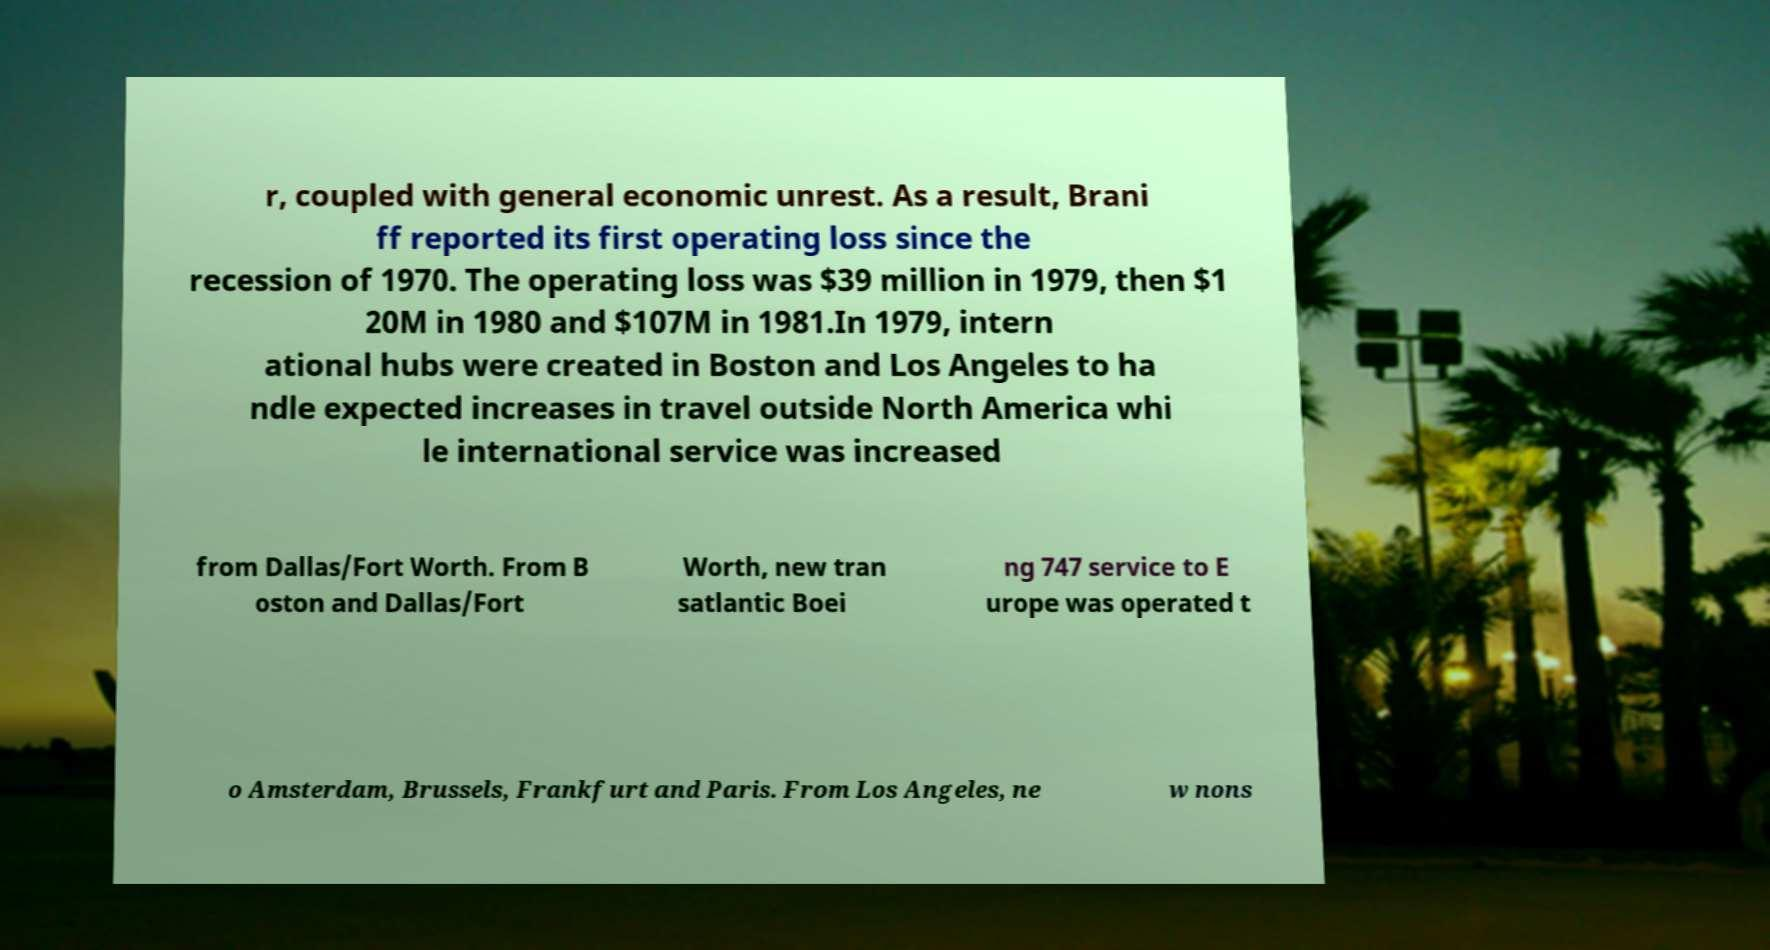For documentation purposes, I need the text within this image transcribed. Could you provide that? r, coupled with general economic unrest. As a result, Brani ff reported its first operating loss since the recession of 1970. The operating loss was $39 million in 1979, then $1 20M in 1980 and $107M in 1981.In 1979, intern ational hubs were created in Boston and Los Angeles to ha ndle expected increases in travel outside North America whi le international service was increased from Dallas/Fort Worth. From B oston and Dallas/Fort Worth, new tran satlantic Boei ng 747 service to E urope was operated t o Amsterdam, Brussels, Frankfurt and Paris. From Los Angeles, ne w nons 